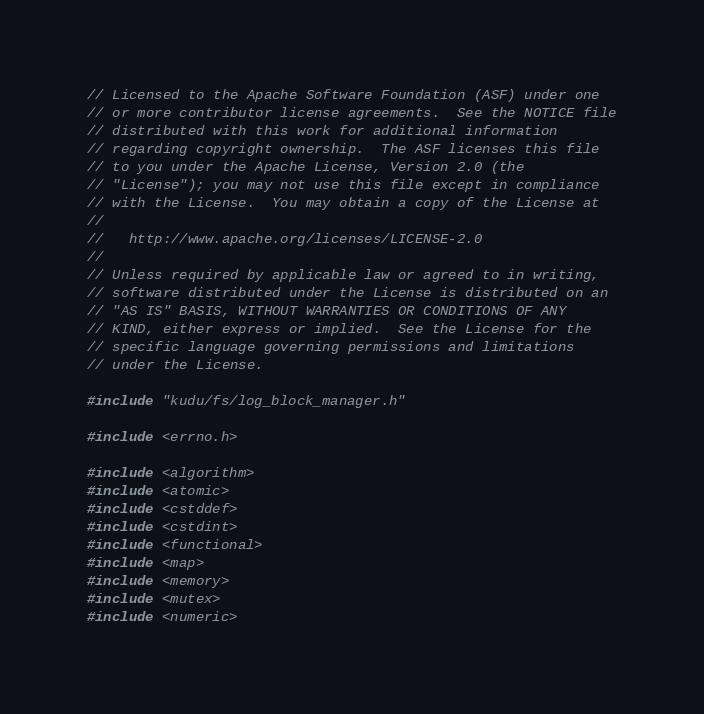<code> <loc_0><loc_0><loc_500><loc_500><_C++_>// Licensed to the Apache Software Foundation (ASF) under one
// or more contributor license agreements.  See the NOTICE file
// distributed with this work for additional information
// regarding copyright ownership.  The ASF licenses this file
// to you under the Apache License, Version 2.0 (the
// "License"); you may not use this file except in compliance
// with the License.  You may obtain a copy of the License at
//
//   http://www.apache.org/licenses/LICENSE-2.0
//
// Unless required by applicable law or agreed to in writing,
// software distributed under the License is distributed on an
// "AS IS" BASIS, WITHOUT WARRANTIES OR CONDITIONS OF ANY
// KIND, either express or implied.  See the License for the
// specific language governing permissions and limitations
// under the License.

#include "kudu/fs/log_block_manager.h"

#include <errno.h>

#include <algorithm>
#include <atomic>
#include <cstddef>
#include <cstdint>
#include <functional>
#include <map>
#include <memory>
#include <mutex>
#include <numeric></code> 